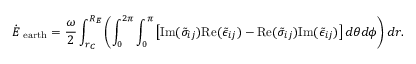<formula> <loc_0><loc_0><loc_500><loc_500>\dot { E } _ { e a r t h } = \frac { \omega } { 2 } \int _ { r _ { C } } ^ { R _ { E } } \left ( \int _ { 0 } ^ { 2 \pi } \int _ { 0 } ^ { \pi } \left [ I m ( \tilde { \sigma } _ { i j } ) R e ( \tilde { \epsilon } _ { i j } ) - R e ( \tilde { \sigma } _ { i j } ) I m ( \tilde { \epsilon } _ { i j } ) \right ] d \theta d \phi \right ) d r .</formula> 